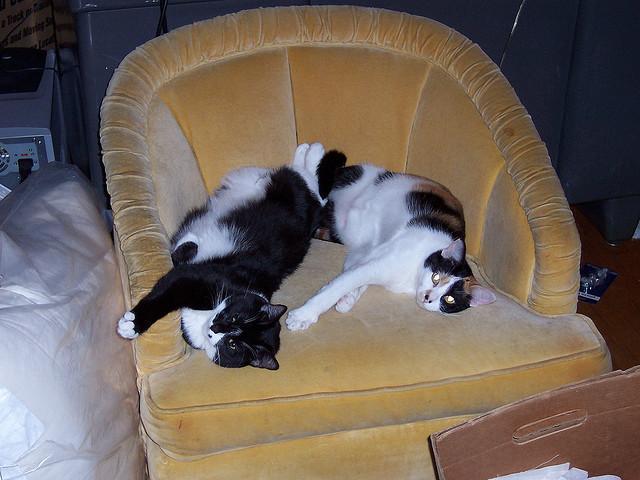How many cats are there?
Give a very brief answer. 2. 